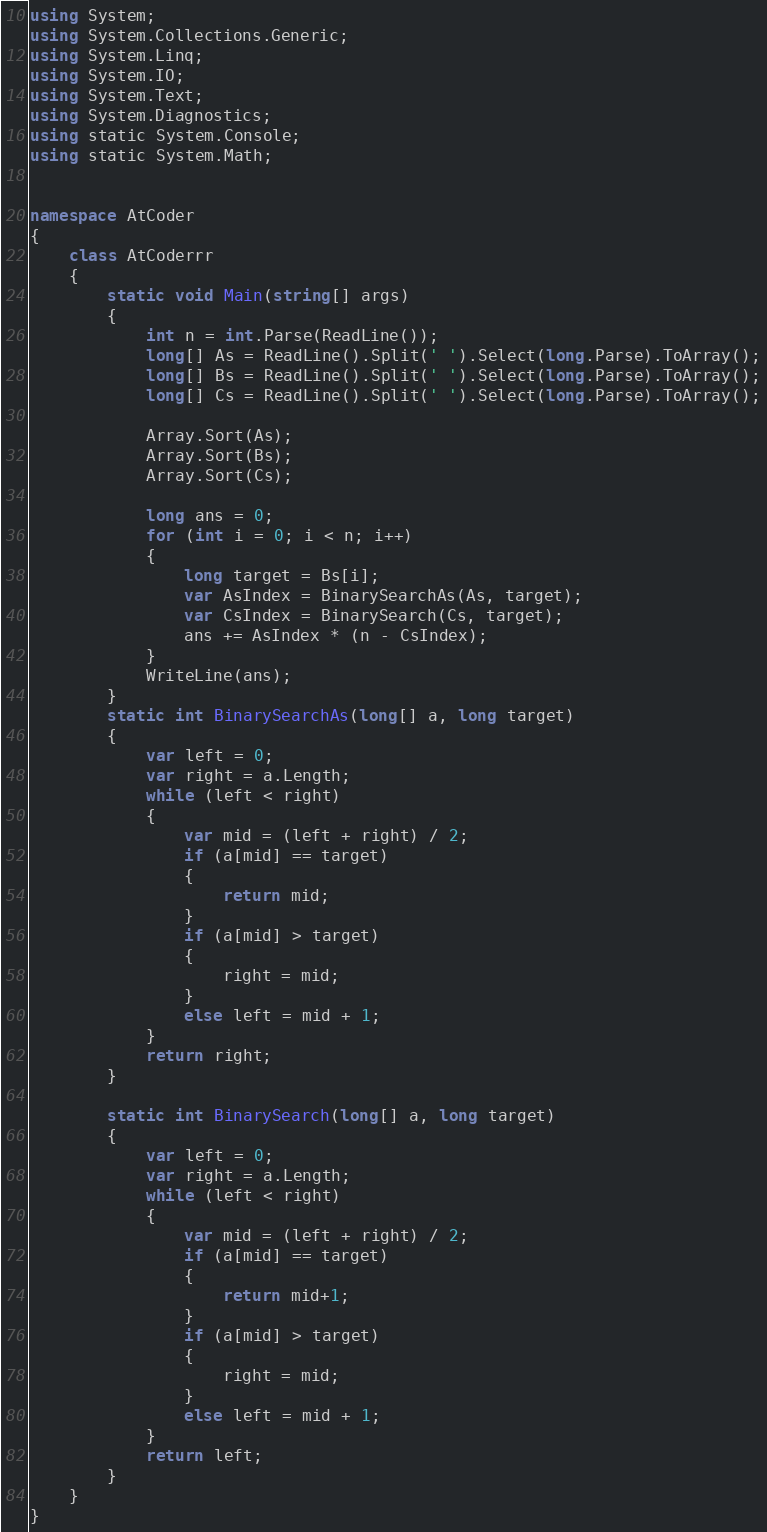<code> <loc_0><loc_0><loc_500><loc_500><_C#_>using System;
using System.Collections.Generic;
using System.Linq;
using System.IO;
using System.Text;
using System.Diagnostics;
using static System.Console;
using static System.Math;


namespace AtCoder
{
    class AtCoderrr
    {
        static void Main(string[] args)
        {
            int n = int.Parse(ReadLine());
            long[] As = ReadLine().Split(' ').Select(long.Parse).ToArray();
            long[] Bs = ReadLine().Split(' ').Select(long.Parse).ToArray();
            long[] Cs = ReadLine().Split(' ').Select(long.Parse).ToArray();

            Array.Sort(As);
            Array.Sort(Bs);
            Array.Sort(Cs);

            long ans = 0;
            for (int i = 0; i < n; i++)
            {
                long target = Bs[i];
                var AsIndex = BinarySearchAs(As, target);
                var CsIndex = BinarySearch(Cs, target);
                ans += AsIndex * (n - CsIndex);
            }
            WriteLine(ans);
        }
        static int BinarySearchAs(long[] a, long target)
        {
            var left = 0;
            var right = a.Length;
            while (left < right)
            {
                var mid = (left + right) / 2;
                if (a[mid] == target)
                {
                    return mid;
                }
                if (a[mid] > target)
                {
                    right = mid;
                }
                else left = mid + 1;
            }
            return right;
        }

        static int BinarySearch(long[] a, long target)
        {
            var left = 0;
            var right = a.Length;
            while (left < right)
            {
                var mid = (left + right) / 2;
                if (a[mid] == target)
                {
                    return mid+1;
                }
                if (a[mid] > target)
                {
                    right = mid;
                }
                else left = mid + 1;
            }
            return left;
        }
    }
}
</code> 